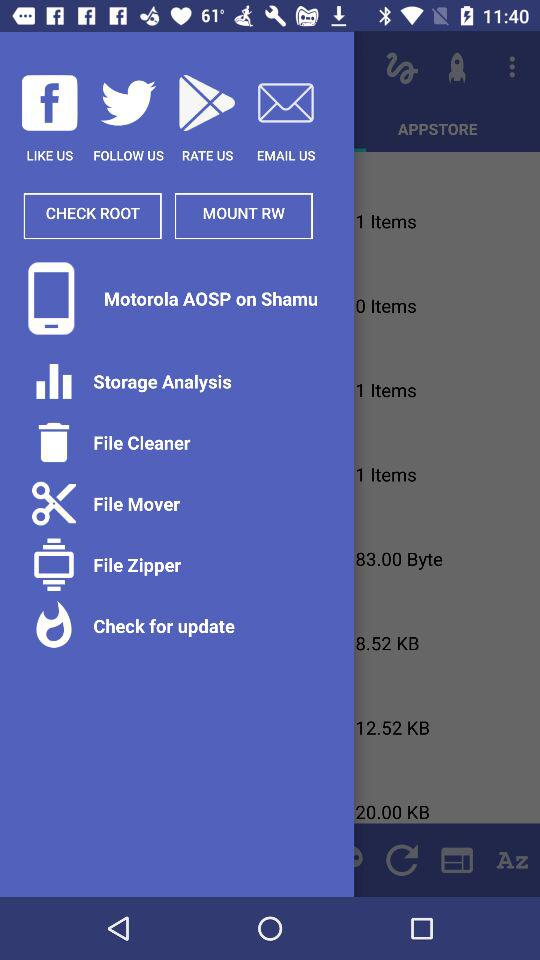What option is given to follow? The given option to follow is Twitter. 